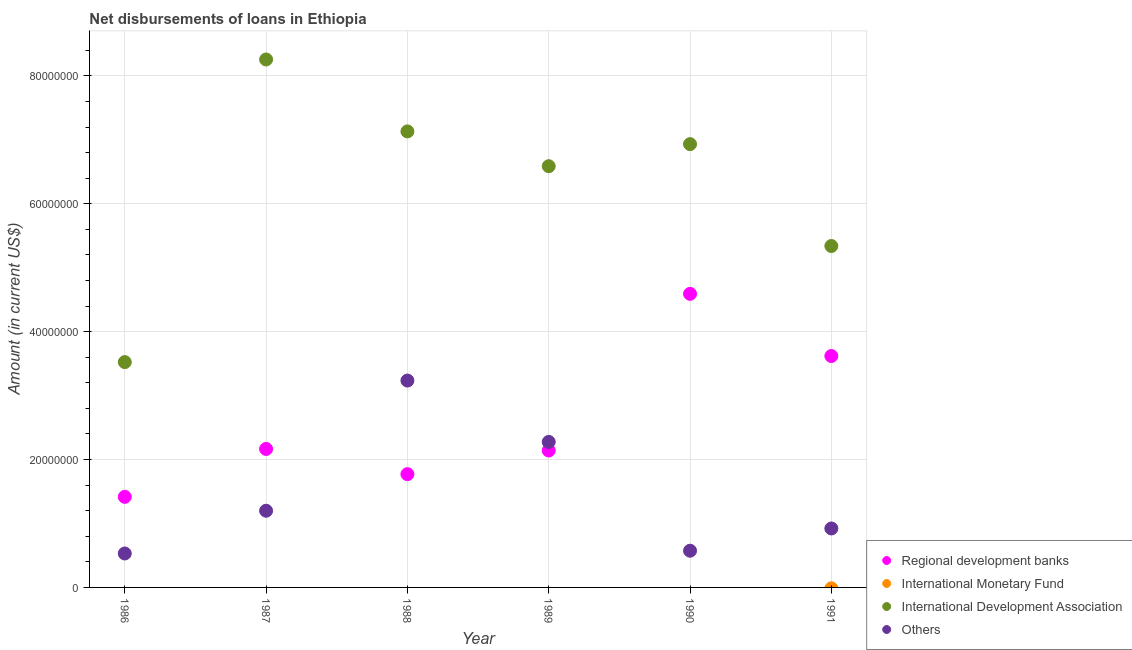What is the amount of loan disimbursed by other organisations in 1987?
Keep it short and to the point. 1.20e+07. Across all years, what is the maximum amount of loan disimbursed by other organisations?
Your answer should be very brief. 3.24e+07. Across all years, what is the minimum amount of loan disimbursed by international development association?
Ensure brevity in your answer.  3.52e+07. In which year was the amount of loan disimbursed by other organisations maximum?
Provide a short and direct response. 1988. What is the total amount of loan disimbursed by regional development banks in the graph?
Provide a succinct answer. 1.57e+08. What is the difference between the amount of loan disimbursed by regional development banks in 1988 and that in 1989?
Make the answer very short. -3.70e+06. What is the difference between the amount of loan disimbursed by regional development banks in 1987 and the amount of loan disimbursed by other organisations in 1988?
Keep it short and to the point. -1.07e+07. What is the average amount of loan disimbursed by other organisations per year?
Your answer should be compact. 1.46e+07. In the year 1987, what is the difference between the amount of loan disimbursed by other organisations and amount of loan disimbursed by international development association?
Offer a terse response. -7.06e+07. In how many years, is the amount of loan disimbursed by international development association greater than 76000000 US$?
Keep it short and to the point. 1. What is the ratio of the amount of loan disimbursed by regional development banks in 1990 to that in 1991?
Your response must be concise. 1.27. Is the amount of loan disimbursed by regional development banks in 1987 less than that in 1989?
Ensure brevity in your answer.  No. What is the difference between the highest and the second highest amount of loan disimbursed by regional development banks?
Your answer should be very brief. 9.73e+06. What is the difference between the highest and the lowest amount of loan disimbursed by international development association?
Your response must be concise. 4.73e+07. In how many years, is the amount of loan disimbursed by international monetary fund greater than the average amount of loan disimbursed by international monetary fund taken over all years?
Offer a very short reply. 0. Is the amount of loan disimbursed by other organisations strictly greater than the amount of loan disimbursed by international monetary fund over the years?
Offer a very short reply. Yes. How many dotlines are there?
Make the answer very short. 3. What is the difference between two consecutive major ticks on the Y-axis?
Your answer should be compact. 2.00e+07. Does the graph contain any zero values?
Provide a succinct answer. Yes. Does the graph contain grids?
Your answer should be very brief. Yes. Where does the legend appear in the graph?
Your answer should be compact. Bottom right. What is the title of the graph?
Offer a very short reply. Net disbursements of loans in Ethiopia. What is the label or title of the Y-axis?
Give a very brief answer. Amount (in current US$). What is the Amount (in current US$) in Regional development banks in 1986?
Give a very brief answer. 1.42e+07. What is the Amount (in current US$) of International Monetary Fund in 1986?
Offer a very short reply. 0. What is the Amount (in current US$) of International Development Association in 1986?
Offer a very short reply. 3.52e+07. What is the Amount (in current US$) of Others in 1986?
Provide a succinct answer. 5.31e+06. What is the Amount (in current US$) of Regional development banks in 1987?
Offer a terse response. 2.17e+07. What is the Amount (in current US$) in International Development Association in 1987?
Your response must be concise. 8.26e+07. What is the Amount (in current US$) of Others in 1987?
Ensure brevity in your answer.  1.20e+07. What is the Amount (in current US$) in Regional development banks in 1988?
Give a very brief answer. 1.77e+07. What is the Amount (in current US$) in International Development Association in 1988?
Offer a terse response. 7.13e+07. What is the Amount (in current US$) in Others in 1988?
Ensure brevity in your answer.  3.24e+07. What is the Amount (in current US$) of Regional development banks in 1989?
Provide a short and direct response. 2.14e+07. What is the Amount (in current US$) of International Monetary Fund in 1989?
Keep it short and to the point. 0. What is the Amount (in current US$) of International Development Association in 1989?
Offer a terse response. 6.59e+07. What is the Amount (in current US$) in Others in 1989?
Provide a short and direct response. 2.28e+07. What is the Amount (in current US$) in Regional development banks in 1990?
Your answer should be very brief. 4.59e+07. What is the Amount (in current US$) in International Monetary Fund in 1990?
Your response must be concise. 0. What is the Amount (in current US$) of International Development Association in 1990?
Your answer should be very brief. 6.93e+07. What is the Amount (in current US$) of Others in 1990?
Make the answer very short. 5.74e+06. What is the Amount (in current US$) in Regional development banks in 1991?
Make the answer very short. 3.62e+07. What is the Amount (in current US$) of International Development Association in 1991?
Your answer should be very brief. 5.34e+07. What is the Amount (in current US$) of Others in 1991?
Keep it short and to the point. 9.22e+06. Across all years, what is the maximum Amount (in current US$) in Regional development banks?
Give a very brief answer. 4.59e+07. Across all years, what is the maximum Amount (in current US$) in International Development Association?
Make the answer very short. 8.26e+07. Across all years, what is the maximum Amount (in current US$) in Others?
Make the answer very short. 3.24e+07. Across all years, what is the minimum Amount (in current US$) of Regional development banks?
Provide a succinct answer. 1.42e+07. Across all years, what is the minimum Amount (in current US$) in International Development Association?
Give a very brief answer. 3.52e+07. Across all years, what is the minimum Amount (in current US$) in Others?
Ensure brevity in your answer.  5.31e+06. What is the total Amount (in current US$) in Regional development banks in the graph?
Offer a very short reply. 1.57e+08. What is the total Amount (in current US$) in International Monetary Fund in the graph?
Your answer should be compact. 0. What is the total Amount (in current US$) of International Development Association in the graph?
Keep it short and to the point. 3.78e+08. What is the total Amount (in current US$) of Others in the graph?
Make the answer very short. 8.74e+07. What is the difference between the Amount (in current US$) of Regional development banks in 1986 and that in 1987?
Provide a short and direct response. -7.49e+06. What is the difference between the Amount (in current US$) in International Development Association in 1986 and that in 1987?
Provide a succinct answer. -4.73e+07. What is the difference between the Amount (in current US$) of Others in 1986 and that in 1987?
Provide a short and direct response. -6.69e+06. What is the difference between the Amount (in current US$) of Regional development banks in 1986 and that in 1988?
Offer a terse response. -3.55e+06. What is the difference between the Amount (in current US$) of International Development Association in 1986 and that in 1988?
Your answer should be very brief. -3.61e+07. What is the difference between the Amount (in current US$) in Others in 1986 and that in 1988?
Provide a succinct answer. -2.70e+07. What is the difference between the Amount (in current US$) in Regional development banks in 1986 and that in 1989?
Provide a succinct answer. -7.24e+06. What is the difference between the Amount (in current US$) of International Development Association in 1986 and that in 1989?
Give a very brief answer. -3.06e+07. What is the difference between the Amount (in current US$) in Others in 1986 and that in 1989?
Your response must be concise. -1.75e+07. What is the difference between the Amount (in current US$) of Regional development banks in 1986 and that in 1990?
Offer a terse response. -3.18e+07. What is the difference between the Amount (in current US$) in International Development Association in 1986 and that in 1990?
Your response must be concise. -3.41e+07. What is the difference between the Amount (in current US$) in Others in 1986 and that in 1990?
Give a very brief answer. -4.31e+05. What is the difference between the Amount (in current US$) of Regional development banks in 1986 and that in 1991?
Provide a short and direct response. -2.20e+07. What is the difference between the Amount (in current US$) of International Development Association in 1986 and that in 1991?
Offer a very short reply. -1.82e+07. What is the difference between the Amount (in current US$) of Others in 1986 and that in 1991?
Offer a very short reply. -3.91e+06. What is the difference between the Amount (in current US$) of Regional development banks in 1987 and that in 1988?
Offer a terse response. 3.94e+06. What is the difference between the Amount (in current US$) in International Development Association in 1987 and that in 1988?
Provide a short and direct response. 1.12e+07. What is the difference between the Amount (in current US$) in Others in 1987 and that in 1988?
Your answer should be compact. -2.04e+07. What is the difference between the Amount (in current US$) of Regional development banks in 1987 and that in 1989?
Your answer should be very brief. 2.44e+05. What is the difference between the Amount (in current US$) in International Development Association in 1987 and that in 1989?
Provide a short and direct response. 1.67e+07. What is the difference between the Amount (in current US$) of Others in 1987 and that in 1989?
Provide a short and direct response. -1.08e+07. What is the difference between the Amount (in current US$) in Regional development banks in 1987 and that in 1990?
Provide a succinct answer. -2.43e+07. What is the difference between the Amount (in current US$) in International Development Association in 1987 and that in 1990?
Your response must be concise. 1.32e+07. What is the difference between the Amount (in current US$) in Others in 1987 and that in 1990?
Ensure brevity in your answer.  6.26e+06. What is the difference between the Amount (in current US$) of Regional development banks in 1987 and that in 1991?
Provide a succinct answer. -1.45e+07. What is the difference between the Amount (in current US$) in International Development Association in 1987 and that in 1991?
Make the answer very short. 2.92e+07. What is the difference between the Amount (in current US$) of Others in 1987 and that in 1991?
Make the answer very short. 2.77e+06. What is the difference between the Amount (in current US$) in Regional development banks in 1988 and that in 1989?
Keep it short and to the point. -3.70e+06. What is the difference between the Amount (in current US$) of International Development Association in 1988 and that in 1989?
Keep it short and to the point. 5.44e+06. What is the difference between the Amount (in current US$) of Others in 1988 and that in 1989?
Keep it short and to the point. 9.60e+06. What is the difference between the Amount (in current US$) in Regional development banks in 1988 and that in 1990?
Your response must be concise. -2.82e+07. What is the difference between the Amount (in current US$) of International Development Association in 1988 and that in 1990?
Offer a very short reply. 1.99e+06. What is the difference between the Amount (in current US$) of Others in 1988 and that in 1990?
Your response must be concise. 2.66e+07. What is the difference between the Amount (in current US$) of Regional development banks in 1988 and that in 1991?
Offer a terse response. -1.85e+07. What is the difference between the Amount (in current US$) in International Development Association in 1988 and that in 1991?
Offer a terse response. 1.79e+07. What is the difference between the Amount (in current US$) of Others in 1988 and that in 1991?
Your answer should be very brief. 2.31e+07. What is the difference between the Amount (in current US$) of Regional development banks in 1989 and that in 1990?
Ensure brevity in your answer.  -2.45e+07. What is the difference between the Amount (in current US$) of International Development Association in 1989 and that in 1990?
Your response must be concise. -3.45e+06. What is the difference between the Amount (in current US$) of Others in 1989 and that in 1990?
Your answer should be compact. 1.70e+07. What is the difference between the Amount (in current US$) in Regional development banks in 1989 and that in 1991?
Ensure brevity in your answer.  -1.48e+07. What is the difference between the Amount (in current US$) of International Development Association in 1989 and that in 1991?
Provide a succinct answer. 1.25e+07. What is the difference between the Amount (in current US$) of Others in 1989 and that in 1991?
Your answer should be very brief. 1.35e+07. What is the difference between the Amount (in current US$) of Regional development banks in 1990 and that in 1991?
Offer a very short reply. 9.73e+06. What is the difference between the Amount (in current US$) of International Development Association in 1990 and that in 1991?
Make the answer very short. 1.59e+07. What is the difference between the Amount (in current US$) of Others in 1990 and that in 1991?
Give a very brief answer. -3.48e+06. What is the difference between the Amount (in current US$) of Regional development banks in 1986 and the Amount (in current US$) of International Development Association in 1987?
Provide a succinct answer. -6.84e+07. What is the difference between the Amount (in current US$) of Regional development banks in 1986 and the Amount (in current US$) of Others in 1987?
Your response must be concise. 2.18e+06. What is the difference between the Amount (in current US$) in International Development Association in 1986 and the Amount (in current US$) in Others in 1987?
Offer a very short reply. 2.32e+07. What is the difference between the Amount (in current US$) of Regional development banks in 1986 and the Amount (in current US$) of International Development Association in 1988?
Ensure brevity in your answer.  -5.72e+07. What is the difference between the Amount (in current US$) of Regional development banks in 1986 and the Amount (in current US$) of Others in 1988?
Ensure brevity in your answer.  -1.82e+07. What is the difference between the Amount (in current US$) of International Development Association in 1986 and the Amount (in current US$) of Others in 1988?
Your answer should be compact. 2.89e+06. What is the difference between the Amount (in current US$) in Regional development banks in 1986 and the Amount (in current US$) in International Development Association in 1989?
Keep it short and to the point. -5.17e+07. What is the difference between the Amount (in current US$) in Regional development banks in 1986 and the Amount (in current US$) in Others in 1989?
Make the answer very short. -8.59e+06. What is the difference between the Amount (in current US$) of International Development Association in 1986 and the Amount (in current US$) of Others in 1989?
Your response must be concise. 1.25e+07. What is the difference between the Amount (in current US$) of Regional development banks in 1986 and the Amount (in current US$) of International Development Association in 1990?
Give a very brief answer. -5.52e+07. What is the difference between the Amount (in current US$) in Regional development banks in 1986 and the Amount (in current US$) in Others in 1990?
Offer a terse response. 8.43e+06. What is the difference between the Amount (in current US$) of International Development Association in 1986 and the Amount (in current US$) of Others in 1990?
Provide a succinct answer. 2.95e+07. What is the difference between the Amount (in current US$) of Regional development banks in 1986 and the Amount (in current US$) of International Development Association in 1991?
Ensure brevity in your answer.  -3.92e+07. What is the difference between the Amount (in current US$) in Regional development banks in 1986 and the Amount (in current US$) in Others in 1991?
Give a very brief answer. 4.95e+06. What is the difference between the Amount (in current US$) in International Development Association in 1986 and the Amount (in current US$) in Others in 1991?
Provide a succinct answer. 2.60e+07. What is the difference between the Amount (in current US$) in Regional development banks in 1987 and the Amount (in current US$) in International Development Association in 1988?
Offer a terse response. -4.97e+07. What is the difference between the Amount (in current US$) in Regional development banks in 1987 and the Amount (in current US$) in Others in 1988?
Make the answer very short. -1.07e+07. What is the difference between the Amount (in current US$) in International Development Association in 1987 and the Amount (in current US$) in Others in 1988?
Provide a succinct answer. 5.02e+07. What is the difference between the Amount (in current US$) in Regional development banks in 1987 and the Amount (in current US$) in International Development Association in 1989?
Your answer should be compact. -4.42e+07. What is the difference between the Amount (in current US$) of Regional development banks in 1987 and the Amount (in current US$) of Others in 1989?
Provide a short and direct response. -1.10e+06. What is the difference between the Amount (in current US$) in International Development Association in 1987 and the Amount (in current US$) in Others in 1989?
Make the answer very short. 5.98e+07. What is the difference between the Amount (in current US$) of Regional development banks in 1987 and the Amount (in current US$) of International Development Association in 1990?
Ensure brevity in your answer.  -4.77e+07. What is the difference between the Amount (in current US$) of Regional development banks in 1987 and the Amount (in current US$) of Others in 1990?
Ensure brevity in your answer.  1.59e+07. What is the difference between the Amount (in current US$) in International Development Association in 1987 and the Amount (in current US$) in Others in 1990?
Offer a very short reply. 7.68e+07. What is the difference between the Amount (in current US$) of Regional development banks in 1987 and the Amount (in current US$) of International Development Association in 1991?
Ensure brevity in your answer.  -3.17e+07. What is the difference between the Amount (in current US$) of Regional development banks in 1987 and the Amount (in current US$) of Others in 1991?
Your answer should be compact. 1.24e+07. What is the difference between the Amount (in current US$) in International Development Association in 1987 and the Amount (in current US$) in Others in 1991?
Keep it short and to the point. 7.34e+07. What is the difference between the Amount (in current US$) of Regional development banks in 1988 and the Amount (in current US$) of International Development Association in 1989?
Keep it short and to the point. -4.82e+07. What is the difference between the Amount (in current US$) in Regional development banks in 1988 and the Amount (in current US$) in Others in 1989?
Offer a terse response. -5.04e+06. What is the difference between the Amount (in current US$) in International Development Association in 1988 and the Amount (in current US$) in Others in 1989?
Offer a terse response. 4.86e+07. What is the difference between the Amount (in current US$) of Regional development banks in 1988 and the Amount (in current US$) of International Development Association in 1990?
Offer a terse response. -5.16e+07. What is the difference between the Amount (in current US$) of Regional development banks in 1988 and the Amount (in current US$) of Others in 1990?
Offer a terse response. 1.20e+07. What is the difference between the Amount (in current US$) of International Development Association in 1988 and the Amount (in current US$) of Others in 1990?
Offer a very short reply. 6.56e+07. What is the difference between the Amount (in current US$) of Regional development banks in 1988 and the Amount (in current US$) of International Development Association in 1991?
Make the answer very short. -3.57e+07. What is the difference between the Amount (in current US$) in Regional development banks in 1988 and the Amount (in current US$) in Others in 1991?
Your answer should be compact. 8.50e+06. What is the difference between the Amount (in current US$) in International Development Association in 1988 and the Amount (in current US$) in Others in 1991?
Offer a terse response. 6.21e+07. What is the difference between the Amount (in current US$) in Regional development banks in 1989 and the Amount (in current US$) in International Development Association in 1990?
Provide a succinct answer. -4.79e+07. What is the difference between the Amount (in current US$) in Regional development banks in 1989 and the Amount (in current US$) in Others in 1990?
Your answer should be compact. 1.57e+07. What is the difference between the Amount (in current US$) of International Development Association in 1989 and the Amount (in current US$) of Others in 1990?
Your response must be concise. 6.01e+07. What is the difference between the Amount (in current US$) in Regional development banks in 1989 and the Amount (in current US$) in International Development Association in 1991?
Your answer should be compact. -3.20e+07. What is the difference between the Amount (in current US$) in Regional development banks in 1989 and the Amount (in current US$) in Others in 1991?
Make the answer very short. 1.22e+07. What is the difference between the Amount (in current US$) in International Development Association in 1989 and the Amount (in current US$) in Others in 1991?
Provide a succinct answer. 5.67e+07. What is the difference between the Amount (in current US$) of Regional development banks in 1990 and the Amount (in current US$) of International Development Association in 1991?
Your answer should be compact. -7.48e+06. What is the difference between the Amount (in current US$) of Regional development banks in 1990 and the Amount (in current US$) of Others in 1991?
Ensure brevity in your answer.  3.67e+07. What is the difference between the Amount (in current US$) in International Development Association in 1990 and the Amount (in current US$) in Others in 1991?
Give a very brief answer. 6.01e+07. What is the average Amount (in current US$) in Regional development banks per year?
Offer a very short reply. 2.62e+07. What is the average Amount (in current US$) of International Development Association per year?
Your answer should be very brief. 6.30e+07. What is the average Amount (in current US$) of Others per year?
Provide a short and direct response. 1.46e+07. In the year 1986, what is the difference between the Amount (in current US$) of Regional development banks and Amount (in current US$) of International Development Association?
Your answer should be very brief. -2.11e+07. In the year 1986, what is the difference between the Amount (in current US$) of Regional development banks and Amount (in current US$) of Others?
Provide a succinct answer. 8.86e+06. In the year 1986, what is the difference between the Amount (in current US$) of International Development Association and Amount (in current US$) of Others?
Give a very brief answer. 2.99e+07. In the year 1987, what is the difference between the Amount (in current US$) in Regional development banks and Amount (in current US$) in International Development Association?
Give a very brief answer. -6.09e+07. In the year 1987, what is the difference between the Amount (in current US$) of Regional development banks and Amount (in current US$) of Others?
Your response must be concise. 9.66e+06. In the year 1987, what is the difference between the Amount (in current US$) of International Development Association and Amount (in current US$) of Others?
Offer a very short reply. 7.06e+07. In the year 1988, what is the difference between the Amount (in current US$) of Regional development banks and Amount (in current US$) of International Development Association?
Ensure brevity in your answer.  -5.36e+07. In the year 1988, what is the difference between the Amount (in current US$) in Regional development banks and Amount (in current US$) in Others?
Provide a succinct answer. -1.46e+07. In the year 1988, what is the difference between the Amount (in current US$) in International Development Association and Amount (in current US$) in Others?
Offer a very short reply. 3.90e+07. In the year 1989, what is the difference between the Amount (in current US$) in Regional development banks and Amount (in current US$) in International Development Association?
Your answer should be compact. -4.45e+07. In the year 1989, what is the difference between the Amount (in current US$) of Regional development banks and Amount (in current US$) of Others?
Your response must be concise. -1.35e+06. In the year 1989, what is the difference between the Amount (in current US$) in International Development Association and Amount (in current US$) in Others?
Your answer should be very brief. 4.31e+07. In the year 1990, what is the difference between the Amount (in current US$) of Regional development banks and Amount (in current US$) of International Development Association?
Offer a terse response. -2.34e+07. In the year 1990, what is the difference between the Amount (in current US$) in Regional development banks and Amount (in current US$) in Others?
Your answer should be very brief. 4.02e+07. In the year 1990, what is the difference between the Amount (in current US$) of International Development Association and Amount (in current US$) of Others?
Offer a terse response. 6.36e+07. In the year 1991, what is the difference between the Amount (in current US$) of Regional development banks and Amount (in current US$) of International Development Association?
Keep it short and to the point. -1.72e+07. In the year 1991, what is the difference between the Amount (in current US$) in Regional development banks and Amount (in current US$) in Others?
Make the answer very short. 2.70e+07. In the year 1991, what is the difference between the Amount (in current US$) of International Development Association and Amount (in current US$) of Others?
Your answer should be compact. 4.42e+07. What is the ratio of the Amount (in current US$) of Regional development banks in 1986 to that in 1987?
Give a very brief answer. 0.65. What is the ratio of the Amount (in current US$) in International Development Association in 1986 to that in 1987?
Your answer should be compact. 0.43. What is the ratio of the Amount (in current US$) of Others in 1986 to that in 1987?
Your response must be concise. 0.44. What is the ratio of the Amount (in current US$) of Regional development banks in 1986 to that in 1988?
Make the answer very short. 0.8. What is the ratio of the Amount (in current US$) in International Development Association in 1986 to that in 1988?
Offer a very short reply. 0.49. What is the ratio of the Amount (in current US$) in Others in 1986 to that in 1988?
Your answer should be very brief. 0.16. What is the ratio of the Amount (in current US$) in Regional development banks in 1986 to that in 1989?
Provide a succinct answer. 0.66. What is the ratio of the Amount (in current US$) of International Development Association in 1986 to that in 1989?
Offer a terse response. 0.53. What is the ratio of the Amount (in current US$) in Others in 1986 to that in 1989?
Offer a very short reply. 0.23. What is the ratio of the Amount (in current US$) of Regional development banks in 1986 to that in 1990?
Your answer should be very brief. 0.31. What is the ratio of the Amount (in current US$) in International Development Association in 1986 to that in 1990?
Provide a short and direct response. 0.51. What is the ratio of the Amount (in current US$) in Others in 1986 to that in 1990?
Provide a succinct answer. 0.92. What is the ratio of the Amount (in current US$) in Regional development banks in 1986 to that in 1991?
Provide a succinct answer. 0.39. What is the ratio of the Amount (in current US$) in International Development Association in 1986 to that in 1991?
Provide a short and direct response. 0.66. What is the ratio of the Amount (in current US$) of Others in 1986 to that in 1991?
Offer a very short reply. 0.58. What is the ratio of the Amount (in current US$) of Regional development banks in 1987 to that in 1988?
Provide a short and direct response. 1.22. What is the ratio of the Amount (in current US$) in International Development Association in 1987 to that in 1988?
Your response must be concise. 1.16. What is the ratio of the Amount (in current US$) of Others in 1987 to that in 1988?
Keep it short and to the point. 0.37. What is the ratio of the Amount (in current US$) of Regional development banks in 1987 to that in 1989?
Provide a short and direct response. 1.01. What is the ratio of the Amount (in current US$) in International Development Association in 1987 to that in 1989?
Keep it short and to the point. 1.25. What is the ratio of the Amount (in current US$) in Others in 1987 to that in 1989?
Your answer should be very brief. 0.53. What is the ratio of the Amount (in current US$) of Regional development banks in 1987 to that in 1990?
Keep it short and to the point. 0.47. What is the ratio of the Amount (in current US$) in International Development Association in 1987 to that in 1990?
Keep it short and to the point. 1.19. What is the ratio of the Amount (in current US$) of Others in 1987 to that in 1990?
Your answer should be very brief. 2.09. What is the ratio of the Amount (in current US$) of Regional development banks in 1987 to that in 1991?
Your response must be concise. 0.6. What is the ratio of the Amount (in current US$) in International Development Association in 1987 to that in 1991?
Keep it short and to the point. 1.55. What is the ratio of the Amount (in current US$) in Others in 1987 to that in 1991?
Offer a very short reply. 1.3. What is the ratio of the Amount (in current US$) of Regional development banks in 1988 to that in 1989?
Your answer should be very brief. 0.83. What is the ratio of the Amount (in current US$) of International Development Association in 1988 to that in 1989?
Your answer should be very brief. 1.08. What is the ratio of the Amount (in current US$) of Others in 1988 to that in 1989?
Give a very brief answer. 1.42. What is the ratio of the Amount (in current US$) of Regional development banks in 1988 to that in 1990?
Offer a very short reply. 0.39. What is the ratio of the Amount (in current US$) of International Development Association in 1988 to that in 1990?
Your response must be concise. 1.03. What is the ratio of the Amount (in current US$) in Others in 1988 to that in 1990?
Your answer should be very brief. 5.64. What is the ratio of the Amount (in current US$) in Regional development banks in 1988 to that in 1991?
Make the answer very short. 0.49. What is the ratio of the Amount (in current US$) in International Development Association in 1988 to that in 1991?
Your response must be concise. 1.34. What is the ratio of the Amount (in current US$) in Others in 1988 to that in 1991?
Ensure brevity in your answer.  3.51. What is the ratio of the Amount (in current US$) of Regional development banks in 1989 to that in 1990?
Ensure brevity in your answer.  0.47. What is the ratio of the Amount (in current US$) of International Development Association in 1989 to that in 1990?
Make the answer very short. 0.95. What is the ratio of the Amount (in current US$) of Others in 1989 to that in 1990?
Offer a very short reply. 3.97. What is the ratio of the Amount (in current US$) of Regional development banks in 1989 to that in 1991?
Give a very brief answer. 0.59. What is the ratio of the Amount (in current US$) of International Development Association in 1989 to that in 1991?
Ensure brevity in your answer.  1.23. What is the ratio of the Amount (in current US$) in Others in 1989 to that in 1991?
Keep it short and to the point. 2.47. What is the ratio of the Amount (in current US$) of Regional development banks in 1990 to that in 1991?
Ensure brevity in your answer.  1.27. What is the ratio of the Amount (in current US$) in International Development Association in 1990 to that in 1991?
Keep it short and to the point. 1.3. What is the ratio of the Amount (in current US$) of Others in 1990 to that in 1991?
Offer a very short reply. 0.62. What is the difference between the highest and the second highest Amount (in current US$) of Regional development banks?
Keep it short and to the point. 9.73e+06. What is the difference between the highest and the second highest Amount (in current US$) of International Development Association?
Make the answer very short. 1.12e+07. What is the difference between the highest and the second highest Amount (in current US$) in Others?
Your response must be concise. 9.60e+06. What is the difference between the highest and the lowest Amount (in current US$) of Regional development banks?
Your answer should be very brief. 3.18e+07. What is the difference between the highest and the lowest Amount (in current US$) in International Development Association?
Your response must be concise. 4.73e+07. What is the difference between the highest and the lowest Amount (in current US$) in Others?
Keep it short and to the point. 2.70e+07. 